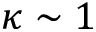Convert formula to latex. <formula><loc_0><loc_0><loc_500><loc_500>\kappa \sim 1</formula> 